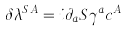Convert formula to latex. <formula><loc_0><loc_0><loc_500><loc_500>\delta \lambda ^ { S \, A } = i \partial _ { a } S \gamma ^ { a } c ^ { A }</formula> 